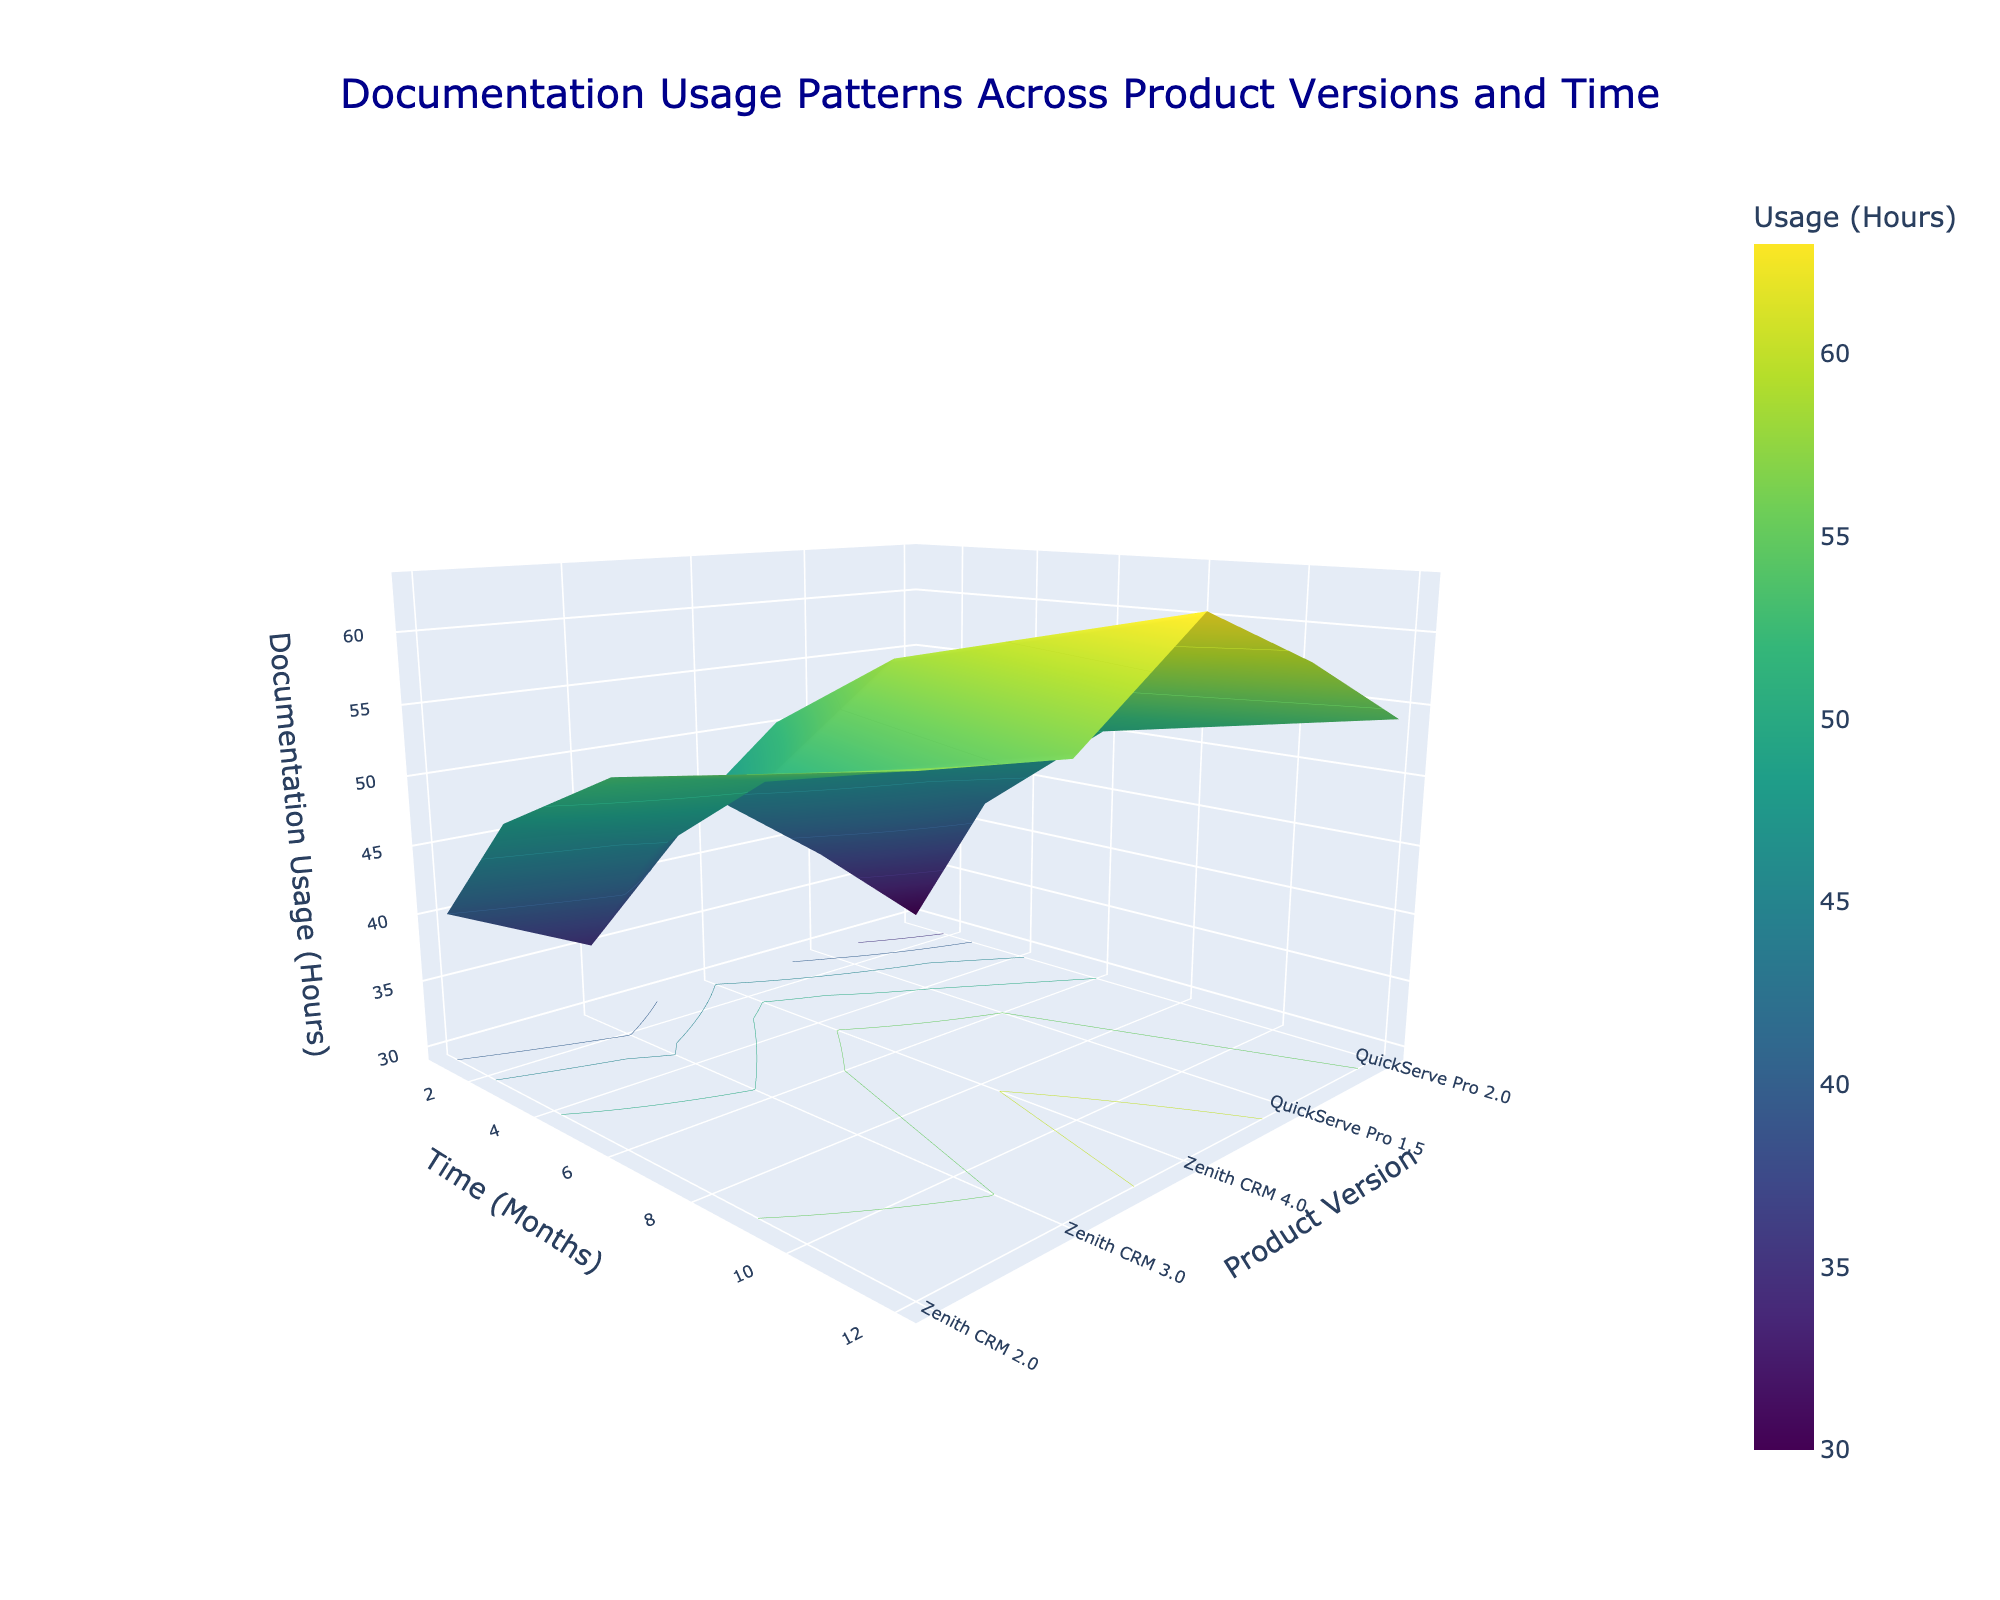What's the title of the figure? The title of a figure is usually displayed at the top of the graph. In this case, it's written as part of the layout configuration. The title "Documentation Usage Patterns Across Product Versions and Time" is placed at the center of the plot.
Answer: Documentation Usage Patterns Across Product Versions and Time What are the axes' labels of the figure? The axes' labels describe what each axis represents. Here, the x-axis is labeled "Time (Months)", the y-axis is labeled "Product Version", and the z-axis is labeled "Documentation Usage (Hours)".
Answer: Time (Months), Product Version, Documentation Usage (Hours) Which product version shows the highest documentation usage at the 12th month? To find the product version with the highest documentation usage at 12 months, look at the z-values on the surface plot where the x-axis is 12 months and compare the heights (z-values) across the different product versions (y-axis). Zenith CRM 2.0 has the highest z-value.
Answer: Zenith CRM 2.0 Is the documentation usage for QuickServe Pro 2.0 higher or lower than QuickServe Pro 1.5 at the 6th month? Check the z-values for QuickServe Pro 2.0 and QuickServe Pro 1.5 where the x-axis is 6 months. QuickServe Pro 1.5 shows a higher z-value compared to QuickServe Pro 2.0.
Answer: Lower On average, how does documentation usage change from 1 month to 12 months? To find this, we consider the general shape of the surface plot. For any given product version, use the z-values at month 1 and month 12. The z-values increase as time progresses from month 1 to month 12, indicating an overall increase in documentation usage.
Answer: Increases Among the product versions shown, which one has the lowest documentation usage across all time points? Observe the entire surface plot. The product version with the consistently lowest z-values across all time points can be identified visually. QuickServe Pro 2.0 has the lowest documentation usage.
Answer: QuickServe Pro 2.0 How does the documentation usage for Zenith CRM 3.0 at 3 months compare with the usage for Zenith CRM 4.0 at 3 months? Examine the z-values for both Zenith CRM 3.0 and Zenith CRM 4.0 where the x-axis is 3 months. Zenith CRM 3.0 has a higher documentation usage.
Answer: Higher What can you infer about the trend in documentation usage for Zenith CRM 2.0 over time? Trace the z-values for Zenith CRM 2.0 from 1 month to 12 months. The z-values show an increasing trend, indicating that documentation usage increases over time.
Answer: Increases What's the difference in documentation usage (in hours) between Zenith CRM 2.0 and Zenith CRM 3.0 at 12 months? Look at the z-values where the x-axis is 12 months for both Zenith CRM 2.0 and Zenith CRM 3.0. Subtract the z-value of Zenith CRM 3.0 from Zenith CRM 2.0 (63 - 59).
Answer: 4 hours Which product version's documentation usage increased the most from 1 month to 6 months? Calculate the increase for each product version by subtracting the z-values at 1 month from those at 6 months. Zenith CRM 2.0 has the highest increase: (58-45) = 13 hours.
Answer: Zenith CRM 2.0 